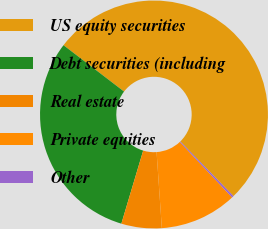<chart> <loc_0><loc_0><loc_500><loc_500><pie_chart><fcel>US equity securities<fcel>Debt securities (including<fcel>Real estate<fcel>Private equities<fcel>Other<nl><fcel>52.31%<fcel>30.78%<fcel>5.72%<fcel>10.92%<fcel>0.27%<nl></chart> 